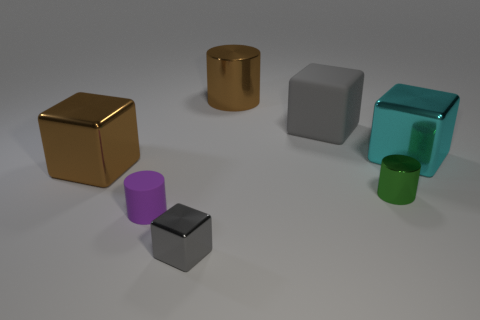There is a tiny shiny object that is on the left side of the big shiny object that is behind the gray matte cube; what is its shape?
Make the answer very short. Cube. There is a metal object that is in front of the small rubber cylinder; does it have the same color as the rubber thing behind the large brown shiny cube?
Ensure brevity in your answer.  Yes. Is there anything else that has the same color as the large metal cylinder?
Offer a very short reply. Yes. There is a big gray thing that is the same shape as the small gray object; what is its material?
Ensure brevity in your answer.  Rubber. Is the color of the metal object that is left of the small metal cube the same as the big cylinder?
Your response must be concise. Yes. What is the shape of the big brown thing in front of the gray cube that is behind the thing on the right side of the tiny shiny cylinder?
Keep it short and to the point. Cube. Do the purple cylinder and the gray object in front of the tiny purple rubber cylinder have the same size?
Your answer should be very brief. Yes. Is there a metallic object that has the same size as the brown cube?
Your answer should be very brief. Yes. How many other things are there of the same material as the big cylinder?
Your response must be concise. 4. There is a big metal thing that is right of the brown cube and in front of the big shiny cylinder; what is its color?
Provide a succinct answer. Cyan. 